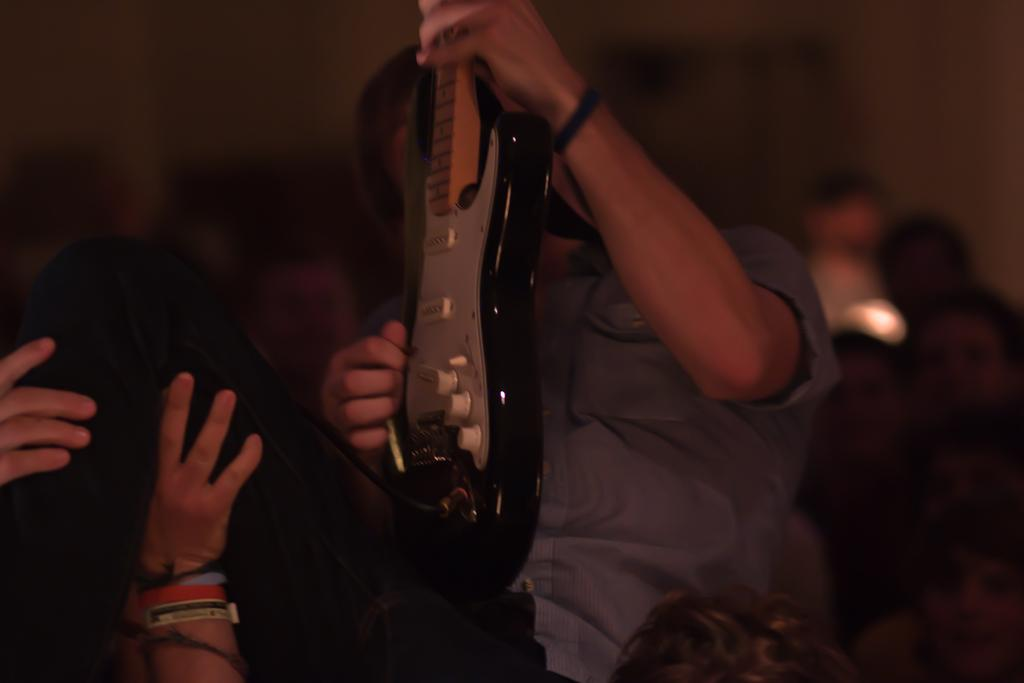What is happening between the two people in the image? One person is lifting another person in the image. Which person is holding a guitar? The person being lifted is holding a guitar. Can you describe the other people visible in the image? There are other people visible in the image, but their actions or roles are not specified. What can be seen in the background of the image? There is a wall in the background of the image. What type of bait is being used to catch fish in the image? There is no mention of fishing or bait in the image; it features two people, one of whom is holding a guitar while being lifted by another person. How is the cork being used in the image? There is no cork present in the image. 